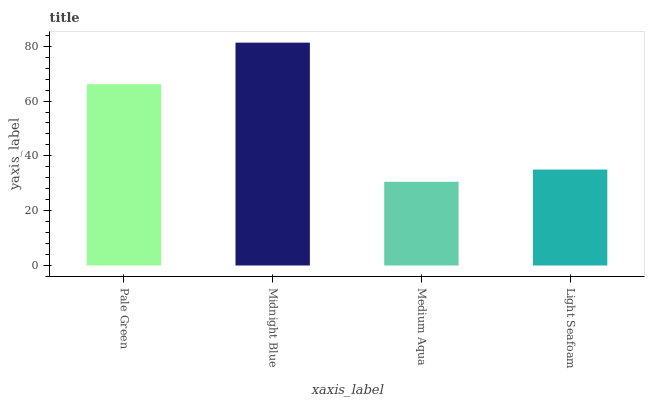Is Medium Aqua the minimum?
Answer yes or no. Yes. Is Midnight Blue the maximum?
Answer yes or no. Yes. Is Midnight Blue the minimum?
Answer yes or no. No. Is Medium Aqua the maximum?
Answer yes or no. No. Is Midnight Blue greater than Medium Aqua?
Answer yes or no. Yes. Is Medium Aqua less than Midnight Blue?
Answer yes or no. Yes. Is Medium Aqua greater than Midnight Blue?
Answer yes or no. No. Is Midnight Blue less than Medium Aqua?
Answer yes or no. No. Is Pale Green the high median?
Answer yes or no. Yes. Is Light Seafoam the low median?
Answer yes or no. Yes. Is Medium Aqua the high median?
Answer yes or no. No. Is Pale Green the low median?
Answer yes or no. No. 